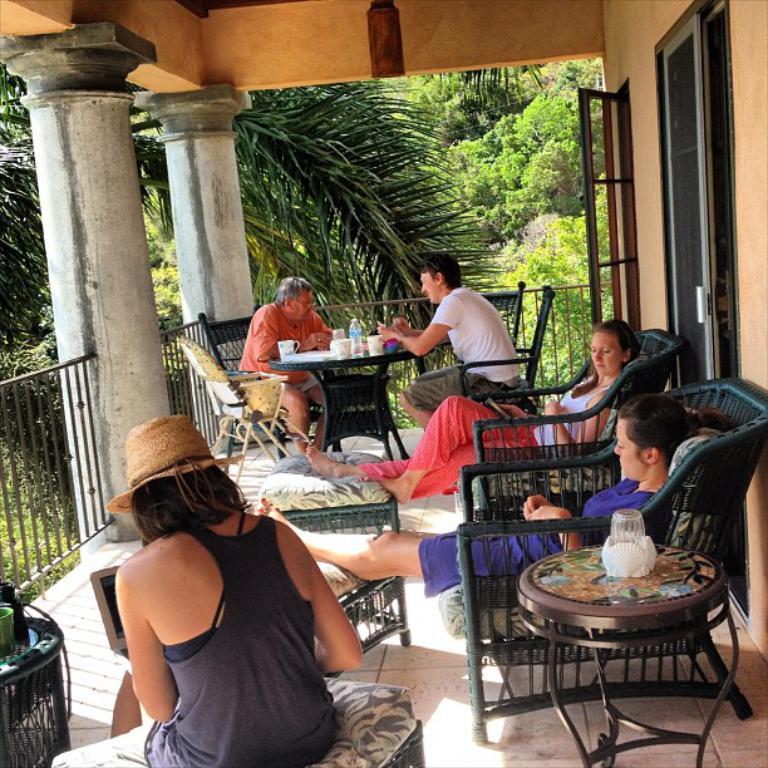How would you summarize this image in a sentence or two? In this picture two women are sitting in the chair. In the middle there are two persons sitting in the chair before table. Front side of the image a person is stiiting on the stool having hat on her head. At the left side there is a stool having cups on it. Background there are few trees. At the right side there is a door. 